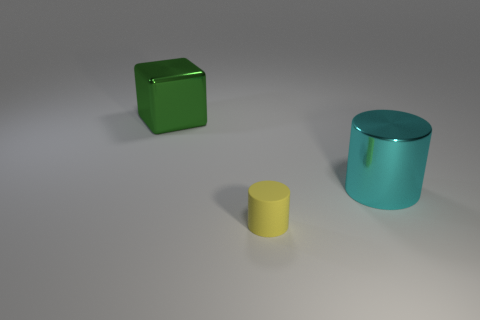Add 3 green objects. How many objects exist? 6 Subtract all cylinders. How many objects are left? 1 Subtract all cyan cylinders. How many cylinders are left? 1 Subtract 1 cylinders. How many cylinders are left? 1 Add 3 large red metallic objects. How many large red metallic objects exist? 3 Subtract 0 brown cylinders. How many objects are left? 3 Subtract all cyan blocks. Subtract all cyan balls. How many blocks are left? 1 Subtract all green cylinders. How many blue cubes are left? 0 Subtract all yellow things. Subtract all metallic blocks. How many objects are left? 1 Add 1 large green metallic cubes. How many large green metallic cubes are left? 2 